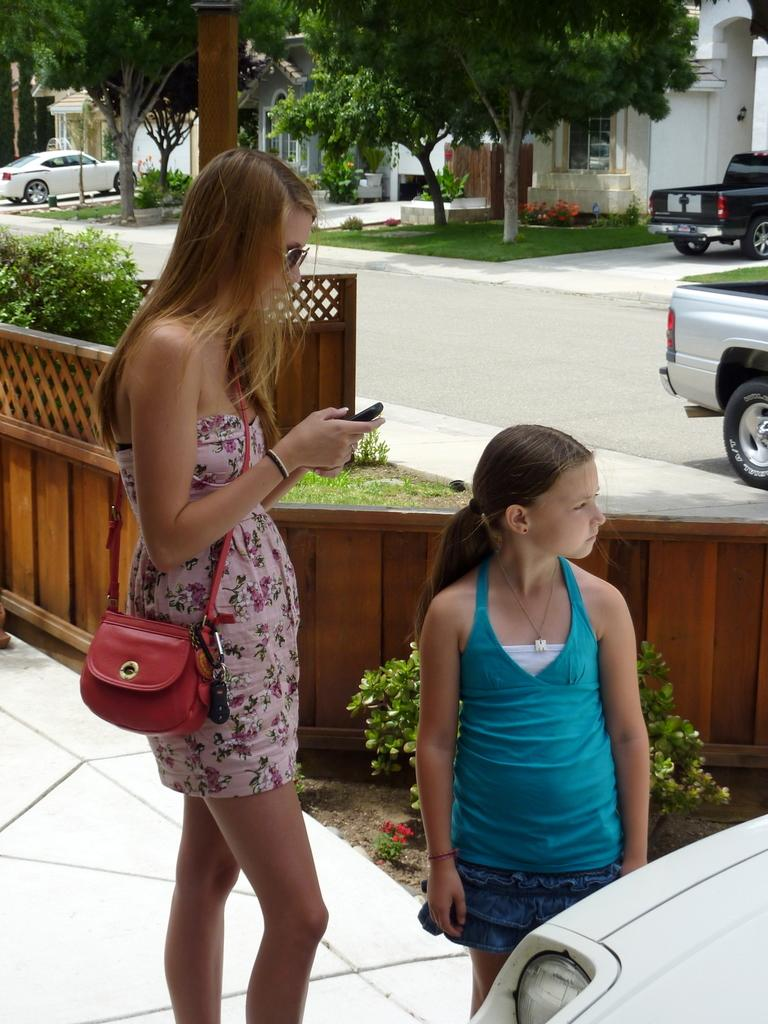How many people are in the image? There are two persons standing in the image. Where are the persons standing? The persons are standing on the floor. What can be seen on the road in the image? There are cars visible on the road in the image. What type of vegetation is present in the image? There are trees present in the image. What type of tooth is visible in the image? There is no tooth present in the image. What color is the collar of the person on the left? There is no collar visible on either person in the image. 